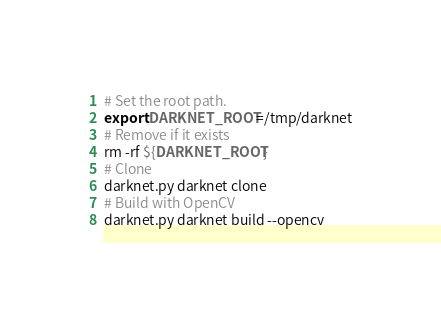<code> <loc_0><loc_0><loc_500><loc_500><_Bash_># Set the root path.
export DARKNET_ROOT=/tmp/darknet
# Remove if it exists
rm -rf ${DARKNET_ROOT}
# Clone
darknet.py darknet clone
# Build with OpenCV
darknet.py darknet build --opencv
</code> 